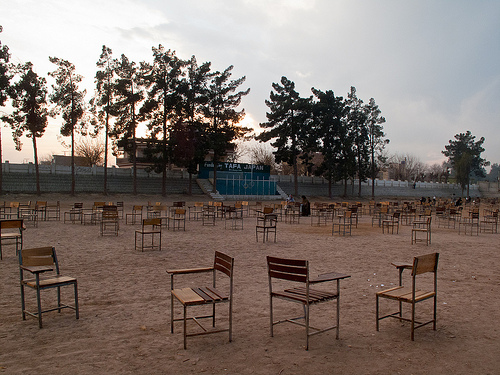<image>
Is there a bleachers next to the tree? Yes. The bleachers is positioned adjacent to the tree, located nearby in the same general area. Is there a tree in front of the chair? No. The tree is not in front of the chair. The spatial positioning shows a different relationship between these objects. 